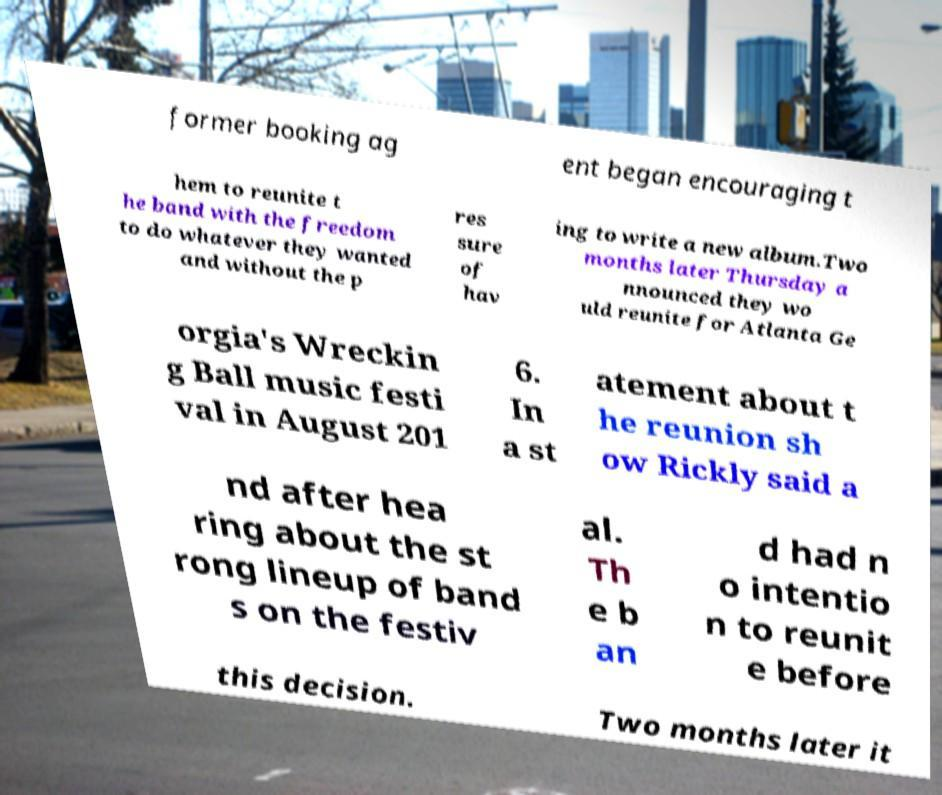Please read and relay the text visible in this image. What does it say? former booking ag ent began encouraging t hem to reunite t he band with the freedom to do whatever they wanted and without the p res sure of hav ing to write a new album.Two months later Thursday a nnounced they wo uld reunite for Atlanta Ge orgia's Wreckin g Ball music festi val in August 201 6. In a st atement about t he reunion sh ow Rickly said a nd after hea ring about the st rong lineup of band s on the festiv al. Th e b an d had n o intentio n to reunit e before this decision. Two months later it 